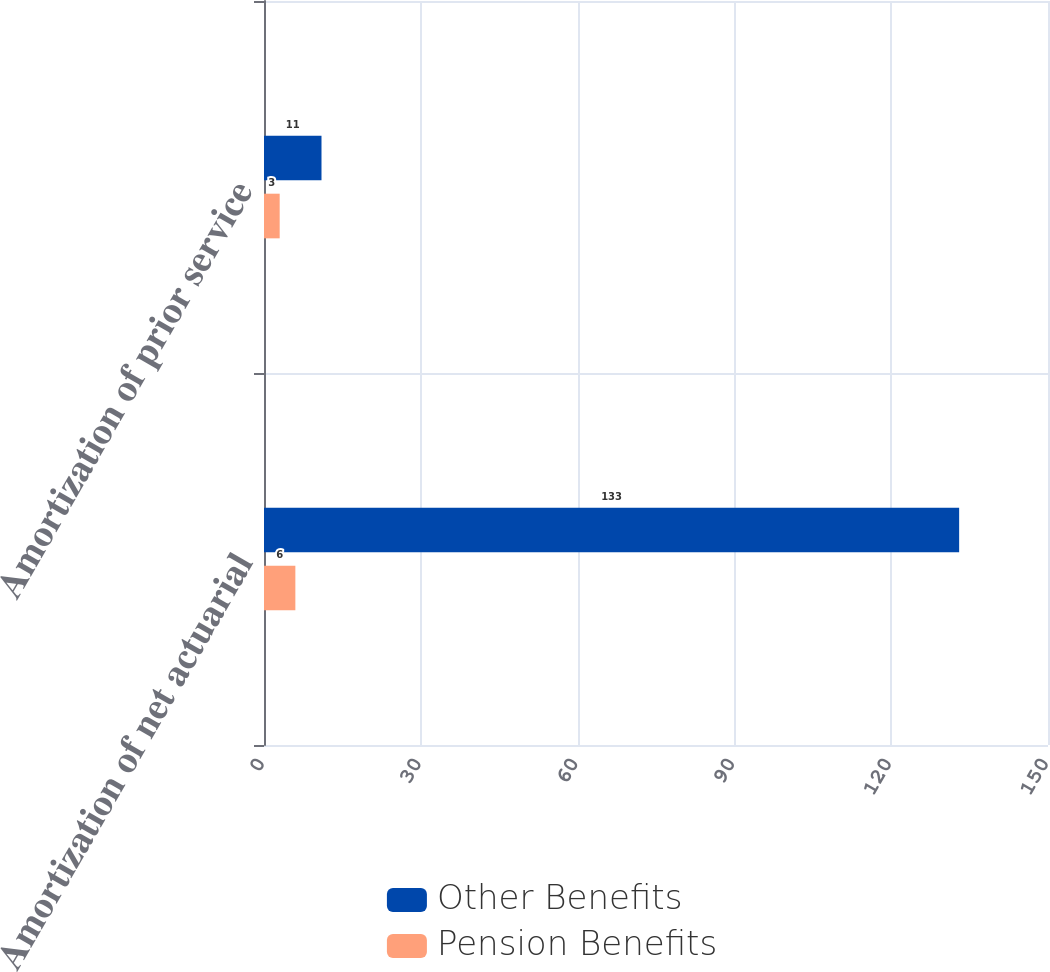Convert chart. <chart><loc_0><loc_0><loc_500><loc_500><stacked_bar_chart><ecel><fcel>Amortization of net actuarial<fcel>Amortization of prior service<nl><fcel>Other Benefits<fcel>133<fcel>11<nl><fcel>Pension Benefits<fcel>6<fcel>3<nl></chart> 